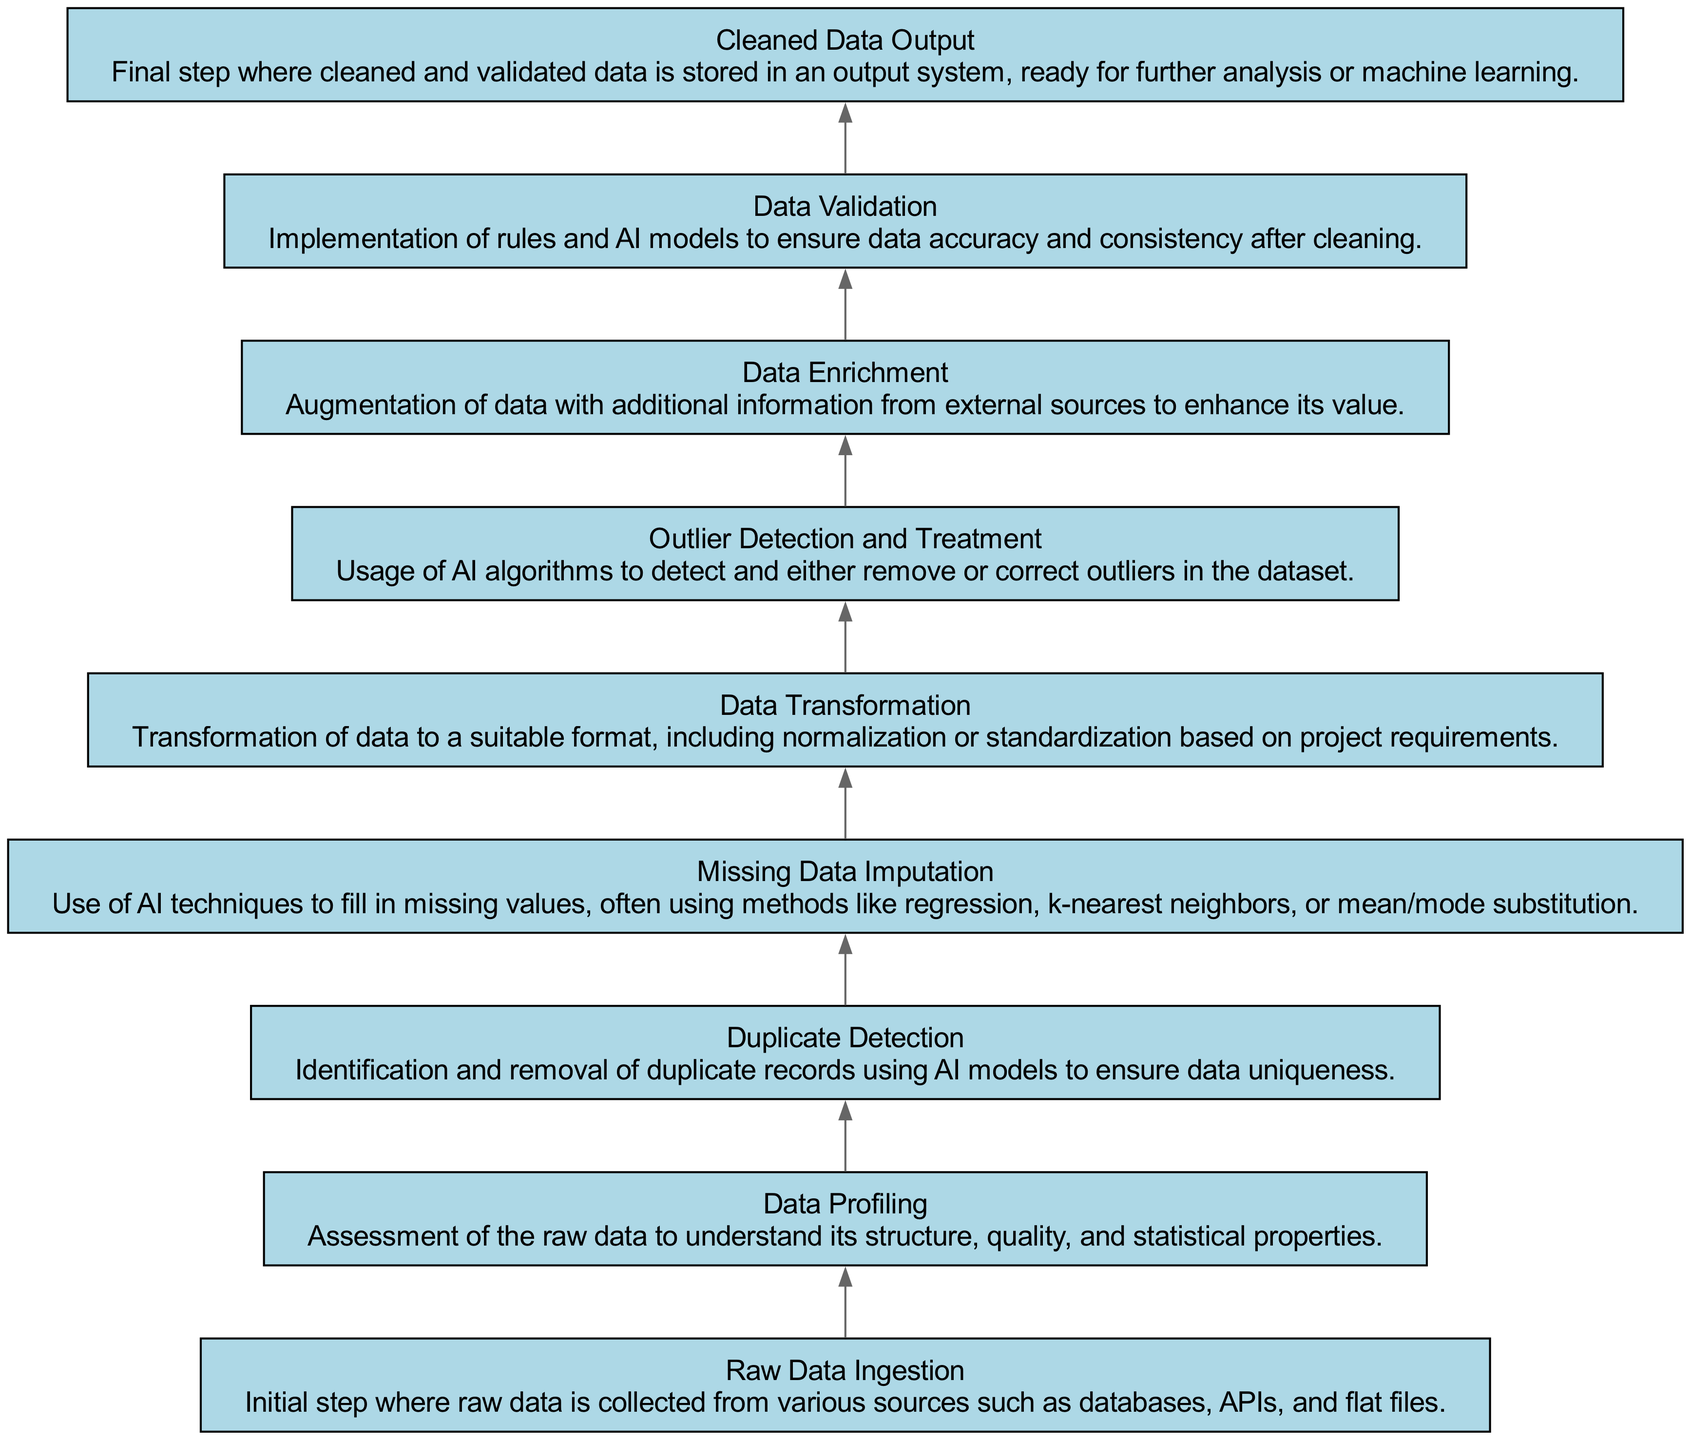What is the first step in the workflow? The first step is "Raw Data Ingestion," which is where raw data is collected from various sources.
Answer: Raw Data Ingestion How many total steps are there in the workflow? There are a total of 9 steps present in the workflow diagram.
Answer: 9 Which step follows "Data Transformation"? The step that follows "Data Transformation" is "Outlier Detection and Treatment."
Answer: Outlier Detection and Treatment What process identifies and removes duplicate records? The process that identifies and removes duplicate records is referred to as "Duplicate Detection."
Answer: Duplicate Detection Which step includes the implementation of rules to ensure data accuracy? The step that includes this implementation is called "Data Validation."
Answer: Data Validation What is the final output of the workflow? The final output of the workflow is "Cleaned Data Output," which signifies the completed cleaning process.
Answer: Cleaned Data Output After "Data Profiling," which step enhances data with additional information? The step that enhances data with additional information after "Data Profiling" is "Data Enrichment."
Answer: Data Enrichment How are missing values addressed in the workflow? Missing values are addressed through "Missing Data Imputation" using AI techniques.
Answer: Missing Data Imputation What is the main focus of the "Outlier Detection and Treatment" step? The main focus is detecting and either removing or correcting outliers in the dataset.
Answer: Detect and treat outliers 